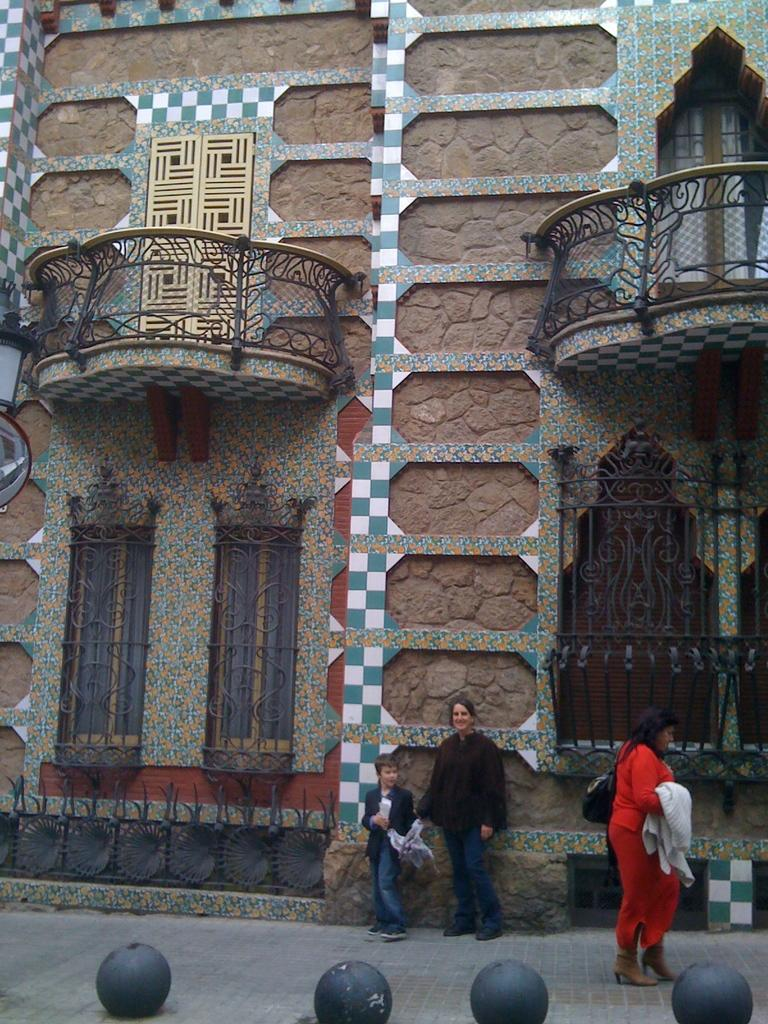What structure is present in the image? There is a building in the image. Who is standing at the bottom of the image? A boy is standing at the bottom of the image. Who is standing beside the boy? A woman is standing beside the boy. Can you describe the woman walking on the right side of the image? The woman walking on the right side of the image is wearing an orange dress. What type of trouble is the boy causing in the image? There is no indication of trouble or any negative actions in the image; the boy is simply standing at the bottom. 